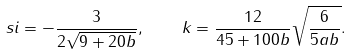Convert formula to latex. <formula><loc_0><loc_0><loc_500><loc_500>\ s i = - \frac { 3 } { 2 \sqrt { 9 + 2 0 b } } , \quad k = \frac { 1 2 } { 4 5 + 1 0 0 b } \sqrt { \frac { 6 } { 5 a b } } .</formula> 